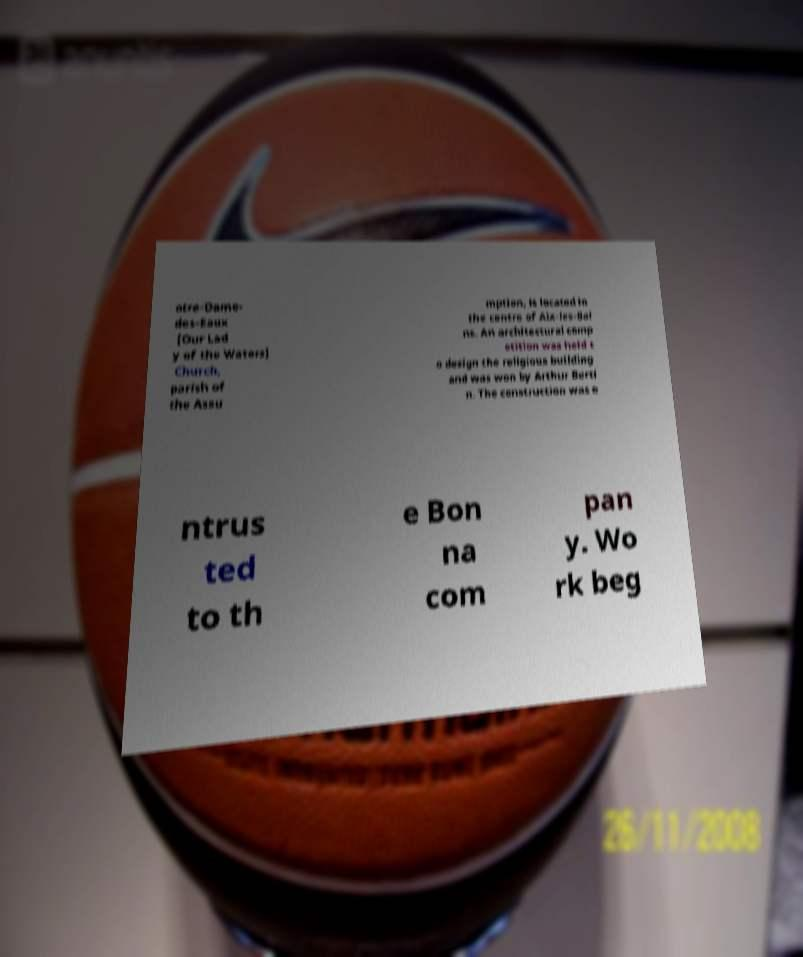I need the written content from this picture converted into text. Can you do that? otre-Dame- des-Eaux [Our Lad y of the Waters] Church, parish of the Assu mption, is located in the centre of Aix-les-Bai ns. An architectural comp etition was held t o design the religious building and was won by Arthur Berti n. The construction was e ntrus ted to th e Bon na com pan y. Wo rk beg 